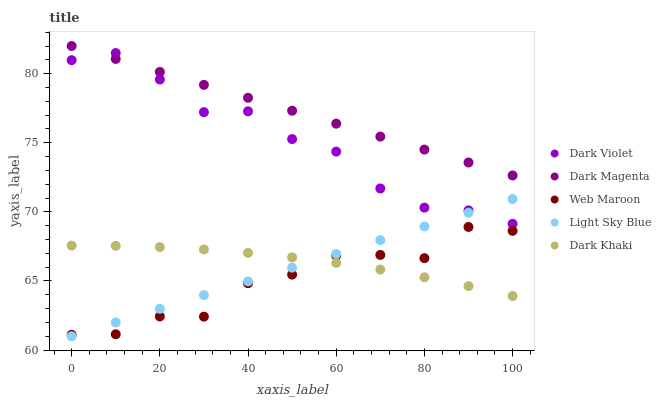Does Web Maroon have the minimum area under the curve?
Answer yes or no. Yes. Does Dark Magenta have the maximum area under the curve?
Answer yes or no. Yes. Does Light Sky Blue have the minimum area under the curve?
Answer yes or no. No. Does Light Sky Blue have the maximum area under the curve?
Answer yes or no. No. Is Dark Magenta the smoothest?
Answer yes or no. Yes. Is Web Maroon the roughest?
Answer yes or no. Yes. Is Light Sky Blue the smoothest?
Answer yes or no. No. Is Light Sky Blue the roughest?
Answer yes or no. No. Does Light Sky Blue have the lowest value?
Answer yes or no. Yes. Does Web Maroon have the lowest value?
Answer yes or no. No. Does Dark Magenta have the highest value?
Answer yes or no. Yes. Does Light Sky Blue have the highest value?
Answer yes or no. No. Is Web Maroon less than Dark Magenta?
Answer yes or no. Yes. Is Dark Violet greater than Dark Khaki?
Answer yes or no. Yes. Does Dark Khaki intersect Light Sky Blue?
Answer yes or no. Yes. Is Dark Khaki less than Light Sky Blue?
Answer yes or no. No. Is Dark Khaki greater than Light Sky Blue?
Answer yes or no. No. Does Web Maroon intersect Dark Magenta?
Answer yes or no. No. 